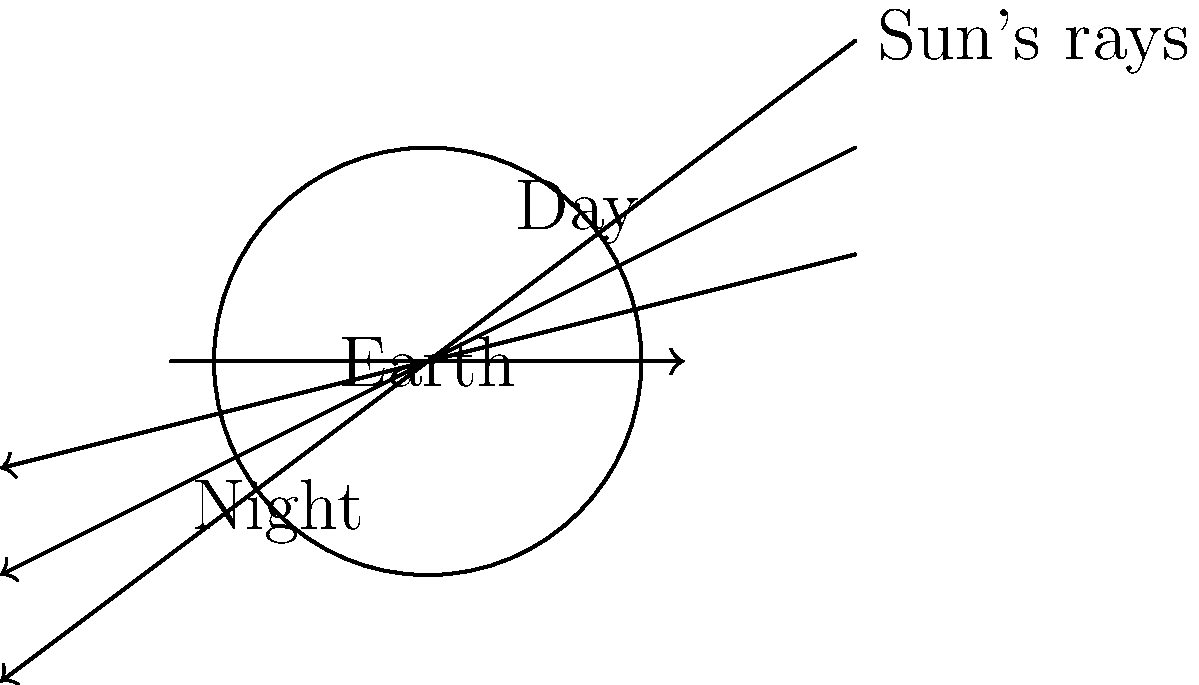In your boxing ring, you've got a globe set up to explain day and night to your young fighters. How would you describe the Earth's rotation and its effect on creating day and night cycles, using this globe as a visual aid? Let's break this down step-by-step, just like we break down a boxing combination:

1. Earth's shape: The Earth is roughly spherical, like our boxing gloves.

2. Earth's axis: Imagine a line running through the Earth from the North Pole to the South Pole. This is Earth's axis of rotation, similar to how a boxer pivots on their feet.

3. Earth's rotation: The Earth spins on this axis, making a complete rotation every 24 hours. This is like a boxer doing a full 360-degree pivot.

4. Sun's position: The Sun, much larger and farther away, remains relatively stationary compared to Earth's rotation. Think of it as the light in the gym ceiling.

5. Sunlight distribution: The Sun's rays hit the Earth, illuminating only half of it at any given time. This is similar to how a spotlight in the ring only illuminates one side of a boxer.

6. Day side: The part of Earth facing the Sun experiences daylight. This is the "day" side, where it's bright like when you're in the ring under the lights.

7. Night side: The part of Earth facing away from the Sun is in darkness. This is the "night" side, like when you're in the shadowy corner of the gym.

8. Continuous rotation: As Earth keeps spinning, different parts move into and out of the sunlight. This creates the cycle of day and night, just like how a boxer moves in and out of the spotlight during a match.

9. Time for full rotation: It takes about 24 hours for Earth to complete one full rotation, which is why we have 24-hour days.
Answer: Earth's 24-hour rotation causes half to face the Sun (day) while the other half faces away (night), creating day-night cycles. 